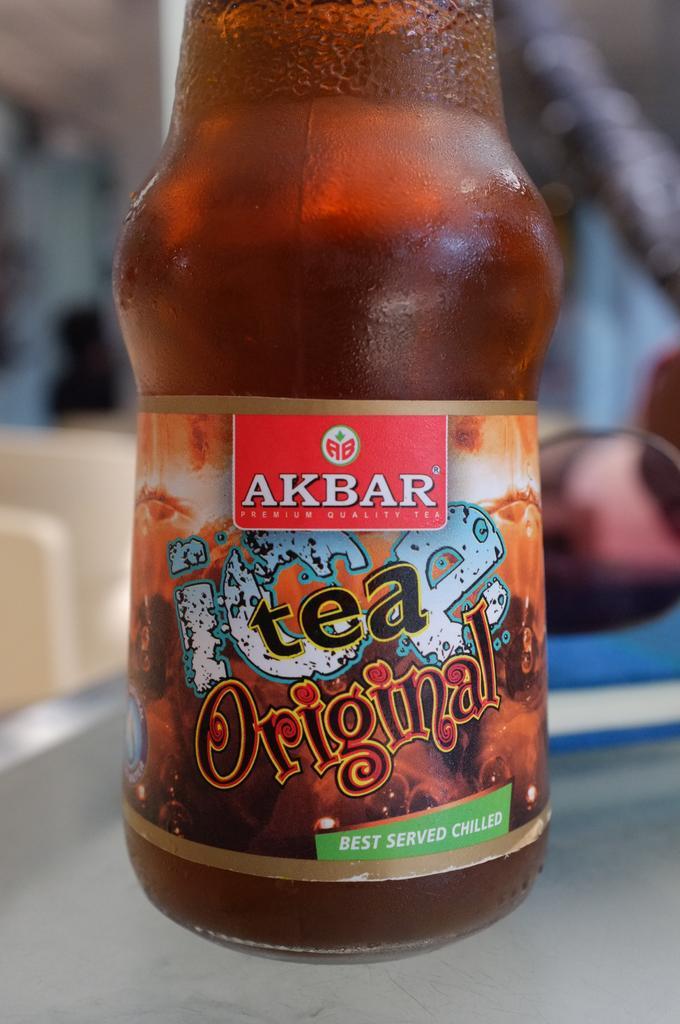How would you summarize this image in a sentence or two? This is a glass bottle which is brown in color. This is a label attached to the label. This bottle is placed on the table. 